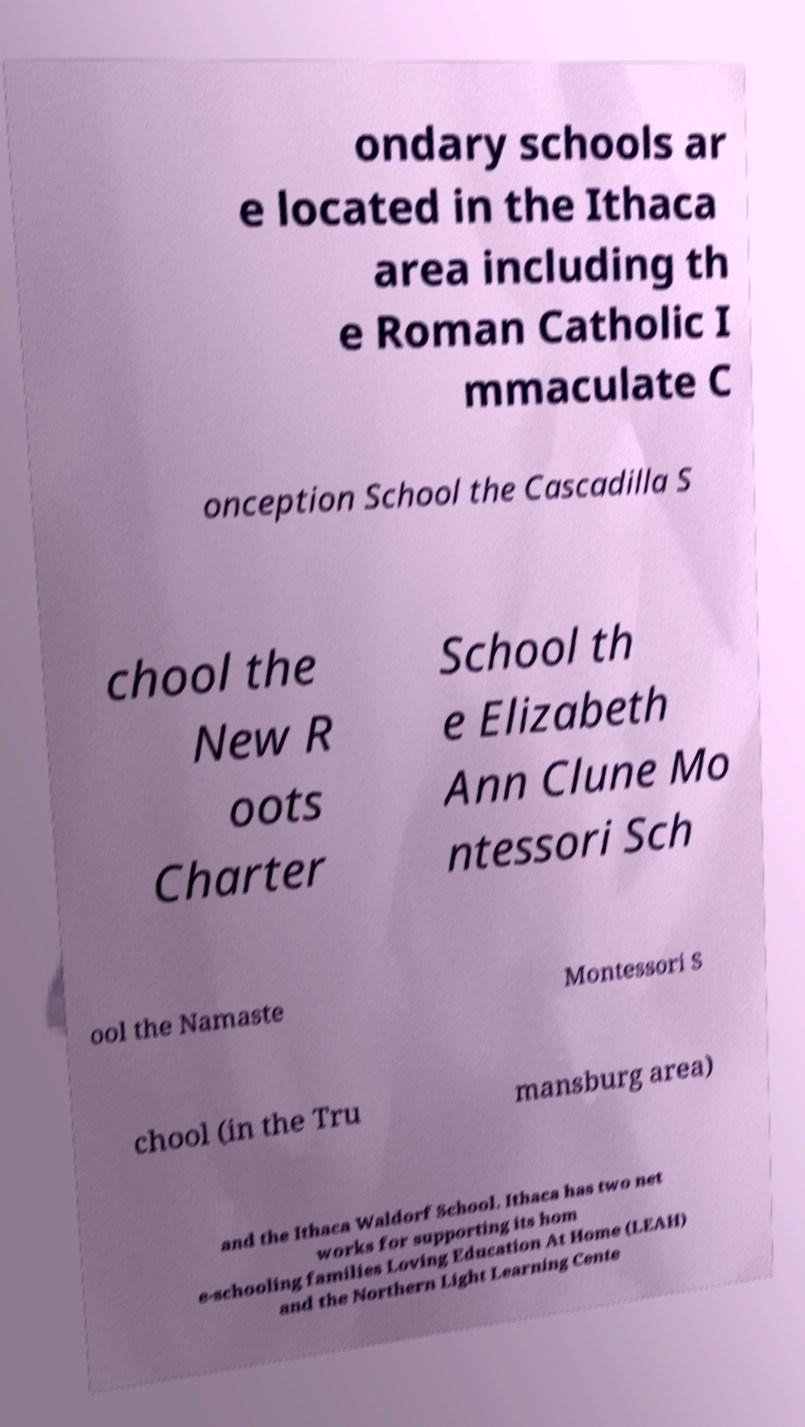I need the written content from this picture converted into text. Can you do that? ondary schools ar e located in the Ithaca area including th e Roman Catholic I mmaculate C onception School the Cascadilla S chool the New R oots Charter School th e Elizabeth Ann Clune Mo ntessori Sch ool the Namaste Montessori S chool (in the Tru mansburg area) and the Ithaca Waldorf School. Ithaca has two net works for supporting its hom e-schooling families Loving Education At Home (LEAH) and the Northern Light Learning Cente 